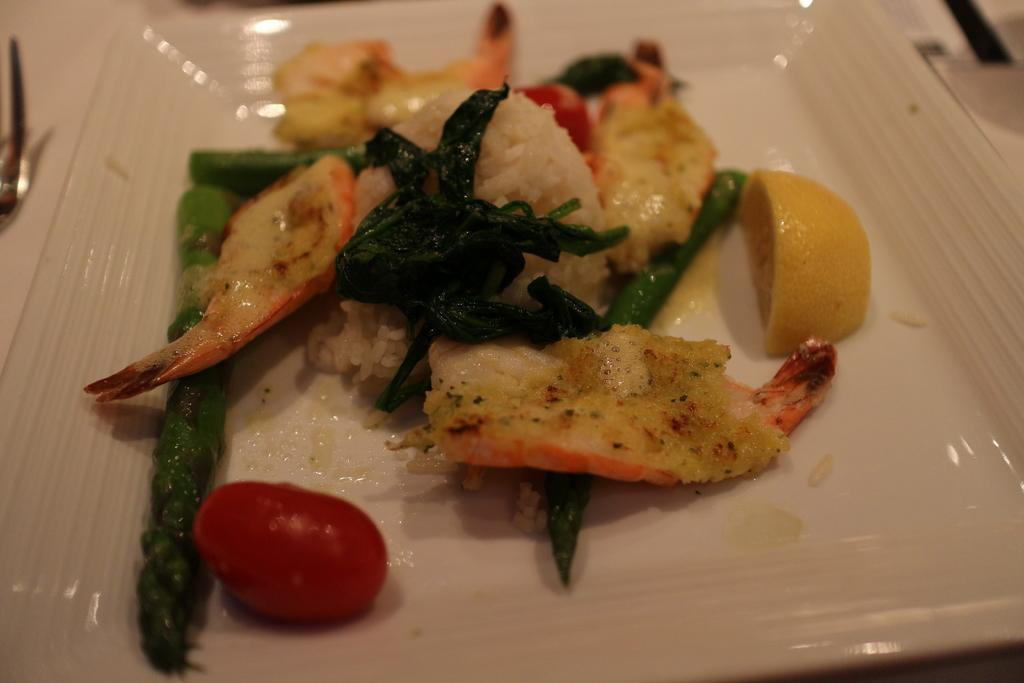What is on the plate that is visible in the image? There is food present on the plate in the image. Can you describe the type of food on the plate? Unfortunately, the type of food cannot be determined from the provided facts. Is there anything else on the plate besides the food? No additional information about the plate is provided in the facts. How does the wind affect the food on the plate in the image? There is no mention of wind in the provided facts, so it cannot be determined how the wind might affect the food on the plate. 